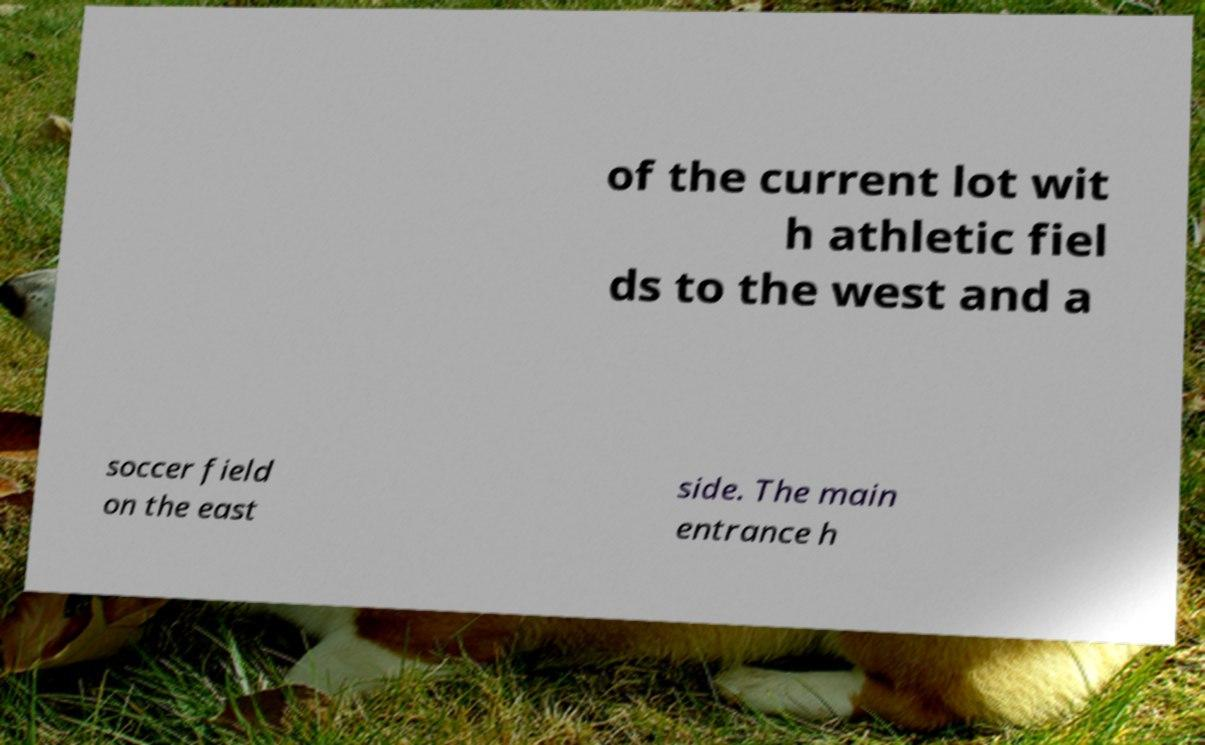What messages or text are displayed in this image? I need them in a readable, typed format. of the current lot wit h athletic fiel ds to the west and a soccer field on the east side. The main entrance h 